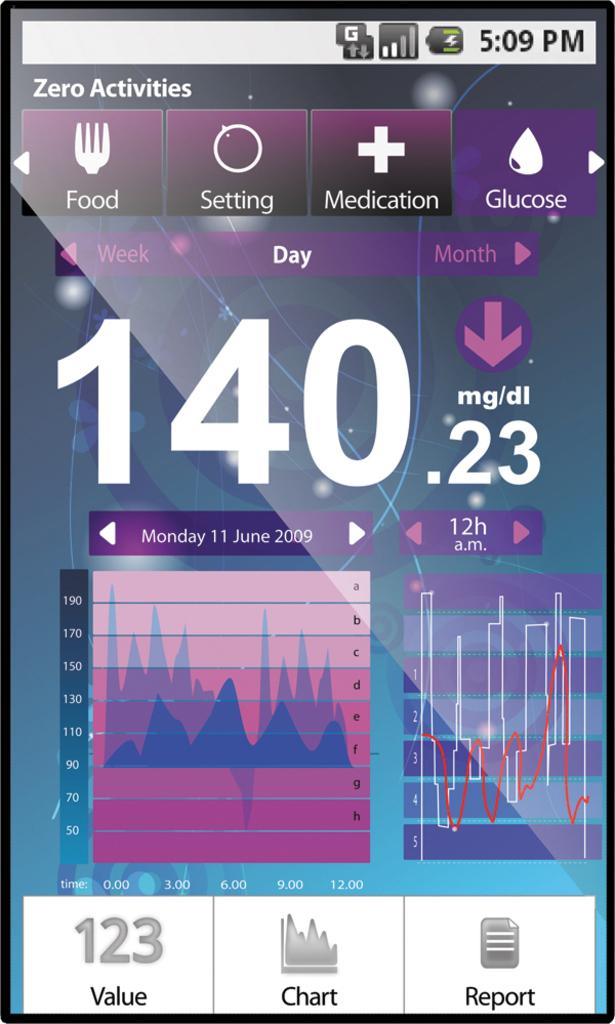<image>
Give a short and clear explanation of the subsequent image. A phone screen says that the time is 5:09 pm and is showing someone's glucose information. 